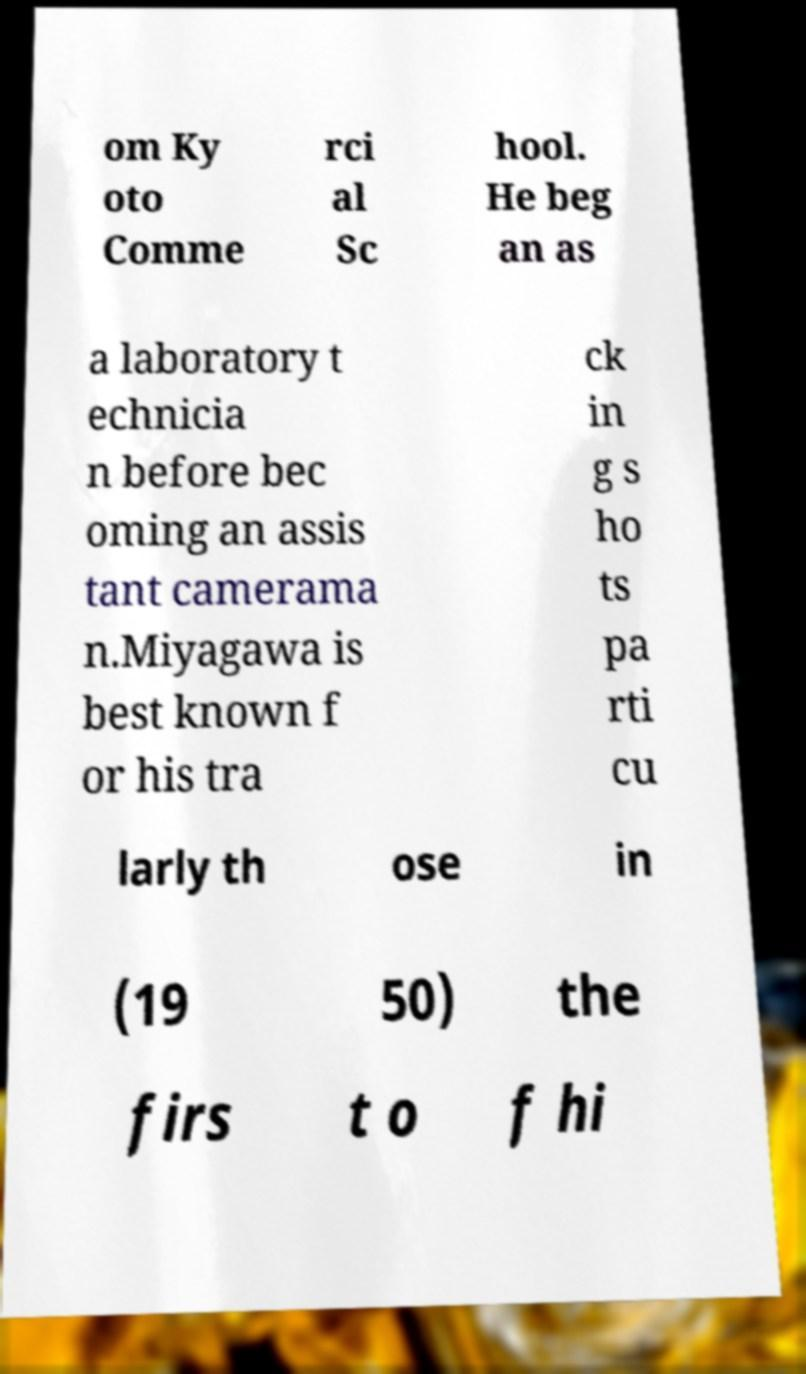There's text embedded in this image that I need extracted. Can you transcribe it verbatim? om Ky oto Comme rci al Sc hool. He beg an as a laboratory t echnicia n before bec oming an assis tant camerama n.Miyagawa is best known f or his tra ck in g s ho ts pa rti cu larly th ose in (19 50) the firs t o f hi 